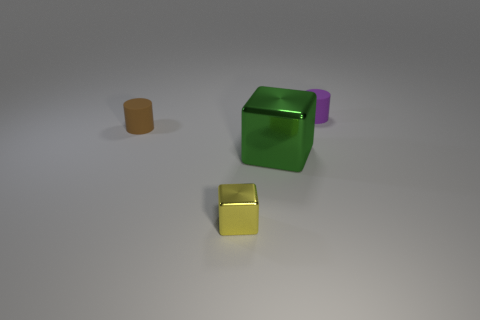Subtract all blue cylinders. Subtract all blue balls. How many cylinders are left? 2 Add 2 brown things. How many objects exist? 6 Add 3 cyan cylinders. How many cyan cylinders exist? 3 Subtract 1 green cubes. How many objects are left? 3 Subtract all small brown cylinders. Subtract all tiny brown cylinders. How many objects are left? 2 Add 1 purple cylinders. How many purple cylinders are left? 2 